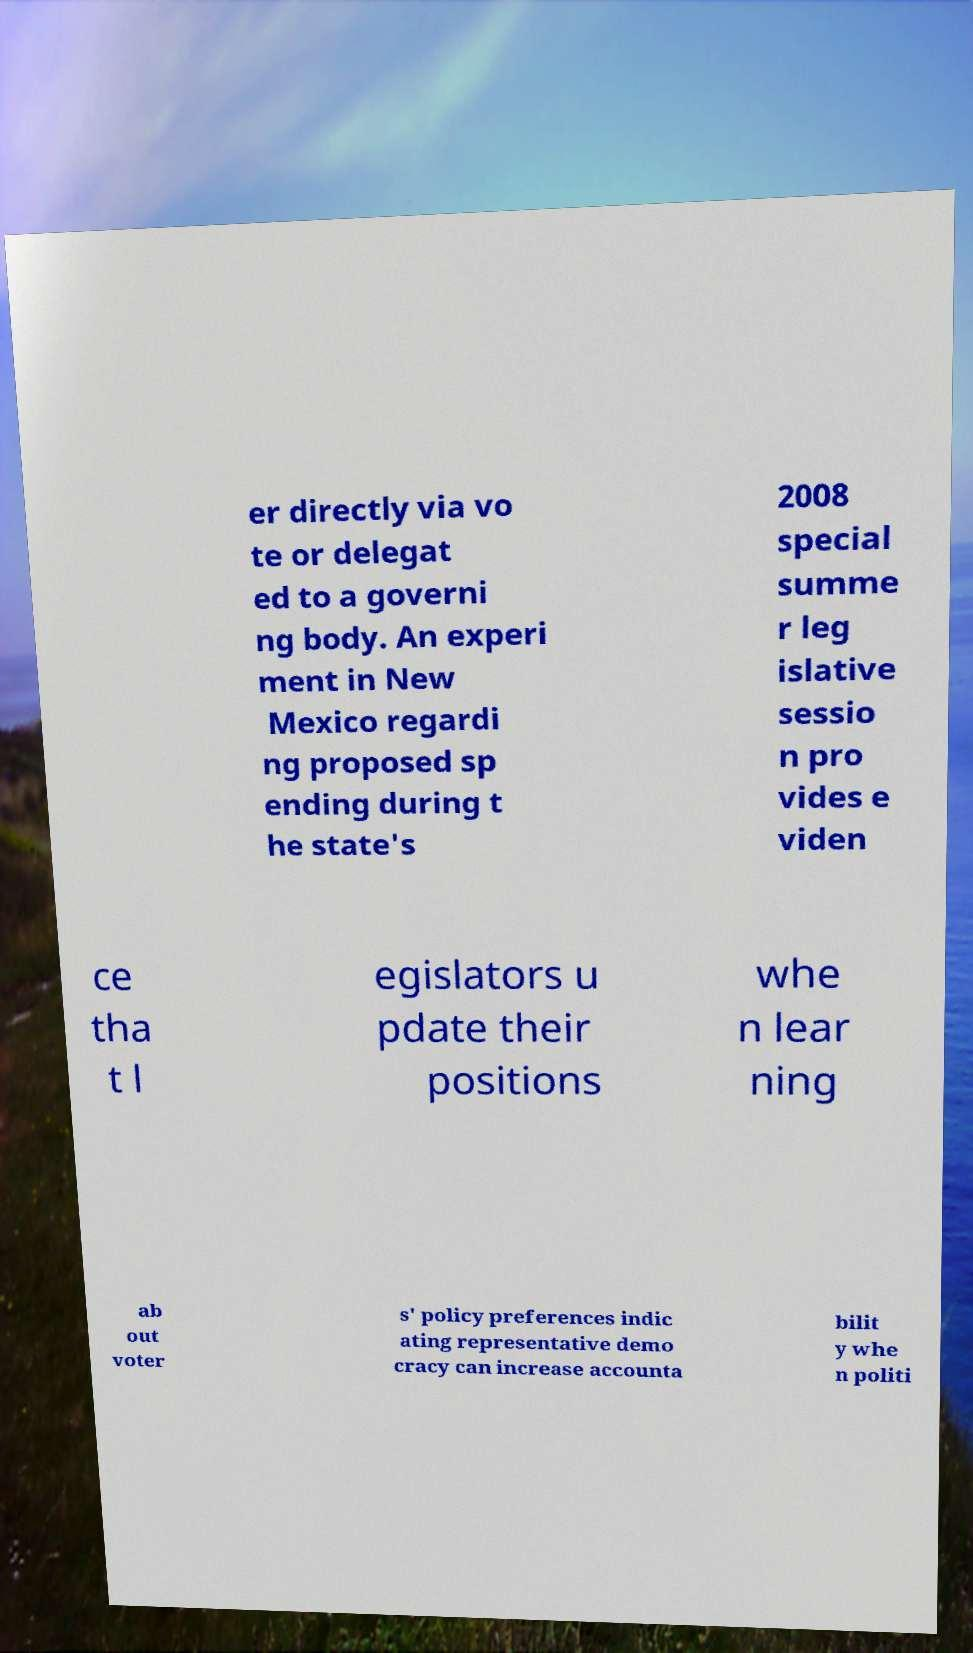Could you extract and type out the text from this image? er directly via vo te or delegat ed to a governi ng body. An experi ment in New Mexico regardi ng proposed sp ending during t he state's 2008 special summe r leg islative sessio n pro vides e viden ce tha t l egislators u pdate their positions whe n lear ning ab out voter s' policy preferences indic ating representative demo cracy can increase accounta bilit y whe n politi 